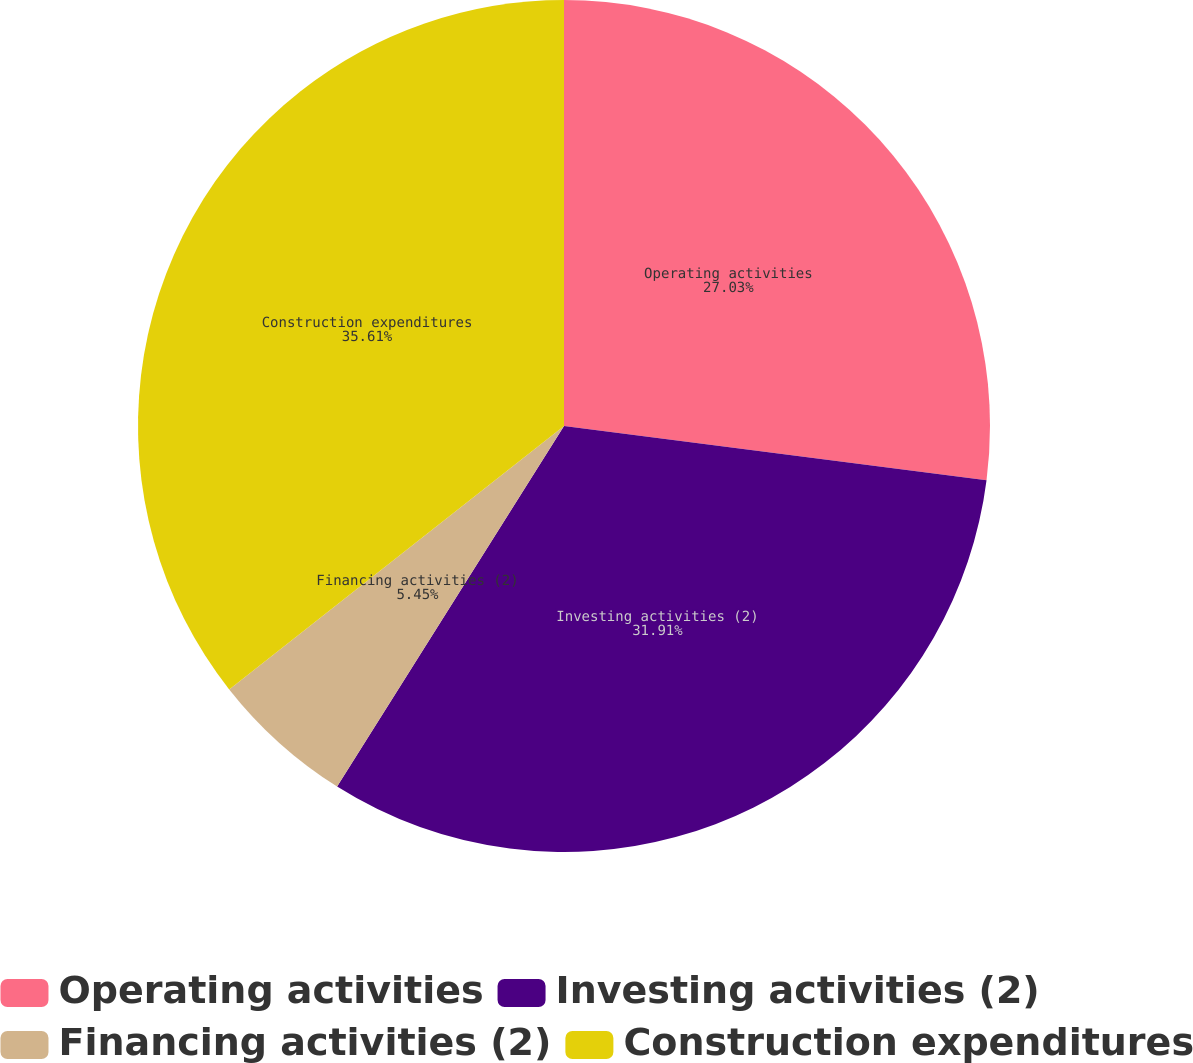Convert chart to OTSL. <chart><loc_0><loc_0><loc_500><loc_500><pie_chart><fcel>Operating activities<fcel>Investing activities (2)<fcel>Financing activities (2)<fcel>Construction expenditures<nl><fcel>27.03%<fcel>31.91%<fcel>5.45%<fcel>35.61%<nl></chart> 